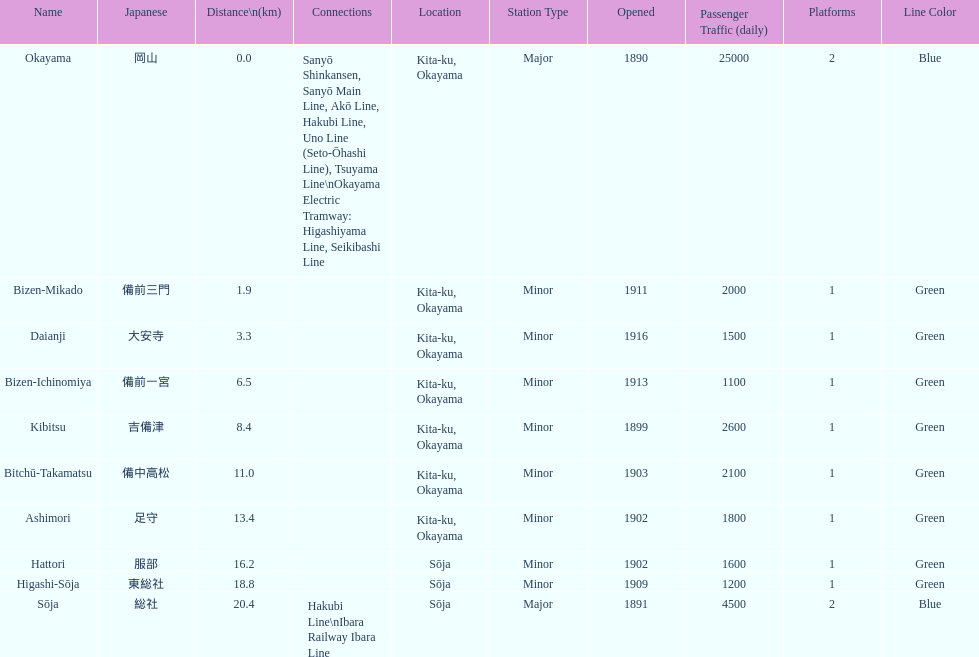How many consecutive stops must you travel through is you board the kibi line at bizen-mikado at depart at kibitsu? 2. 